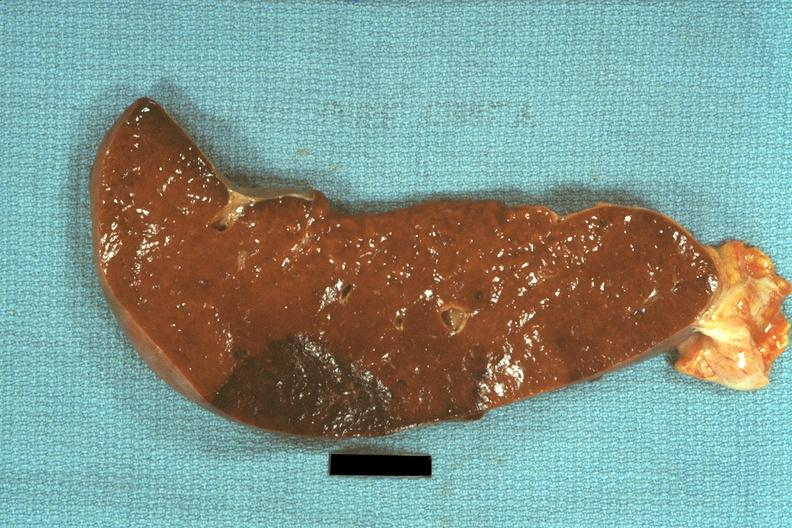what is present?
Answer the question using a single word or phrase. Spleen 